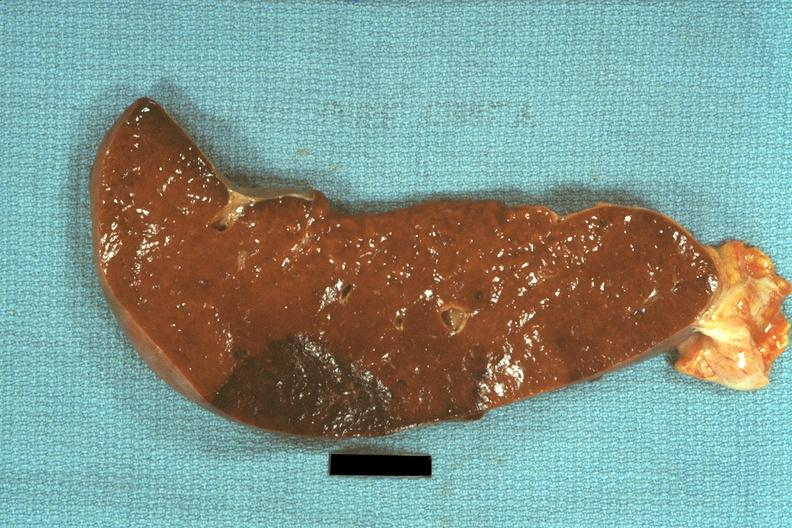what is present?
Answer the question using a single word or phrase. Spleen 